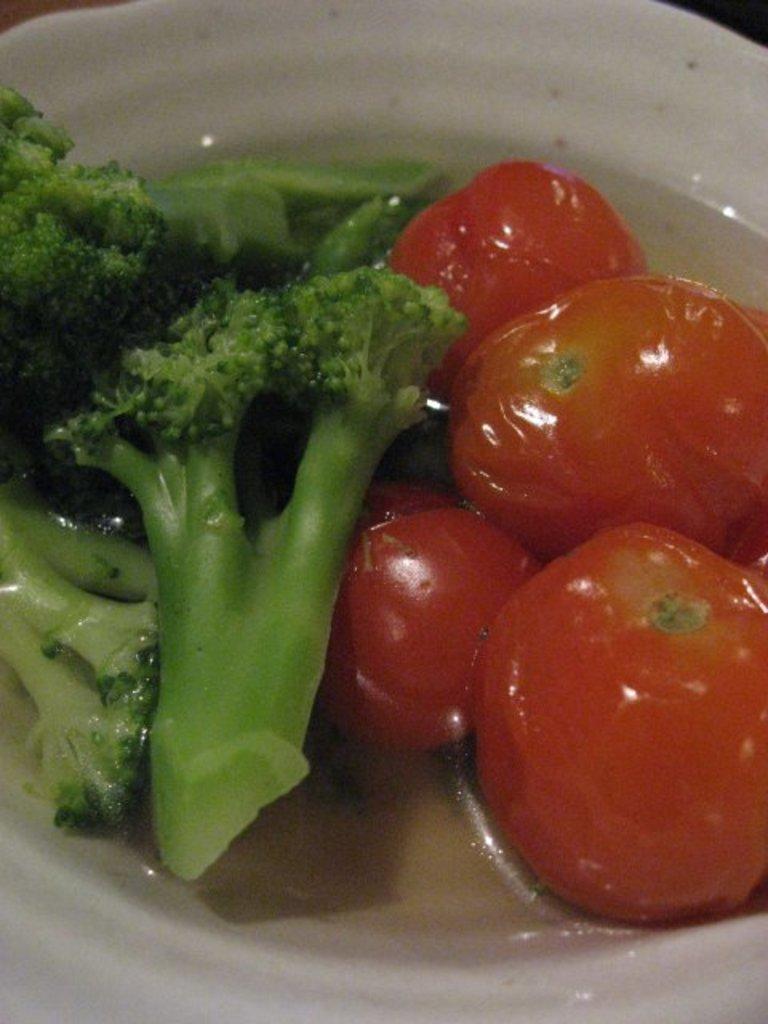Describe this image in one or two sentences. In this picture we can see tomatoes, broccoli pieces on a white plate. 